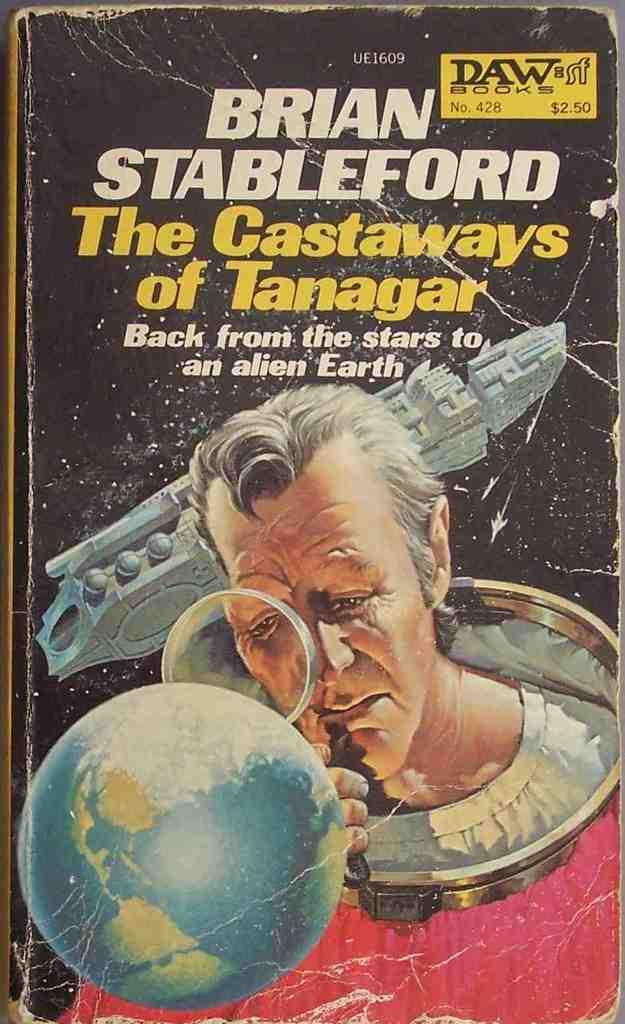<image>
Describe the image concisely. a paperback copy of The Castaways of Tanagar by Brian Stableford 